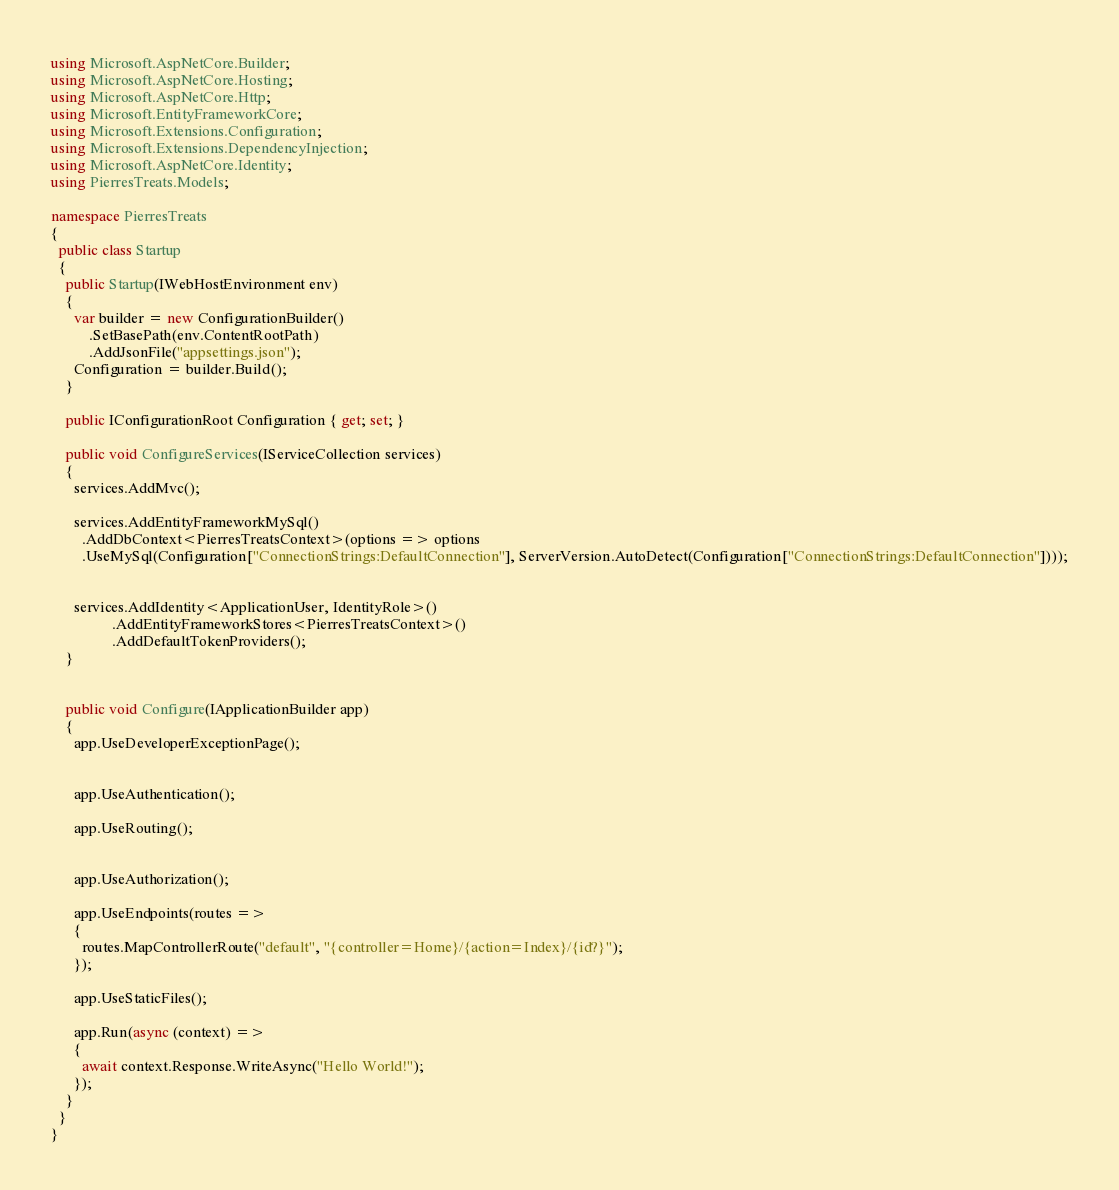<code> <loc_0><loc_0><loc_500><loc_500><_C#_>using Microsoft.AspNetCore.Builder;
using Microsoft.AspNetCore.Hosting;
using Microsoft.AspNetCore.Http;
using Microsoft.EntityFrameworkCore;
using Microsoft.Extensions.Configuration;
using Microsoft.Extensions.DependencyInjection;
using Microsoft.AspNetCore.Identity;
using PierresTreats.Models;

namespace PierresTreats
{
  public class Startup
  {
    public Startup(IWebHostEnvironment env)
    {
      var builder = new ConfigurationBuilder()
          .SetBasePath(env.ContentRootPath)
          .AddJsonFile("appsettings.json");
      Configuration = builder.Build();
    }

    public IConfigurationRoot Configuration { get; set; }

    public void ConfigureServices(IServiceCollection services)
    {
      services.AddMvc();

      services.AddEntityFrameworkMySql()
        .AddDbContext<PierresTreatsContext>(options => options
        .UseMySql(Configuration["ConnectionStrings:DefaultConnection"], ServerVersion.AutoDetect(Configuration["ConnectionStrings:DefaultConnection"])));

  
      services.AddIdentity<ApplicationUser, IdentityRole>()
                .AddEntityFrameworkStores<PierresTreatsContext>()
                .AddDefaultTokenProviders();
    }
    

    public void Configure(IApplicationBuilder app)
    {
      app.UseDeveloperExceptionPage();

     
      app.UseAuthentication(); 

      app.UseRouting();

      
      app.UseAuthorization();

      app.UseEndpoints(routes =>
      {
        routes.MapControllerRoute("default", "{controller=Home}/{action=Index}/{id?}");
      });

      app.UseStaticFiles();

      app.Run(async (context) =>
      {
        await context.Response.WriteAsync("Hello World!");
      });
    }
  }
}</code> 